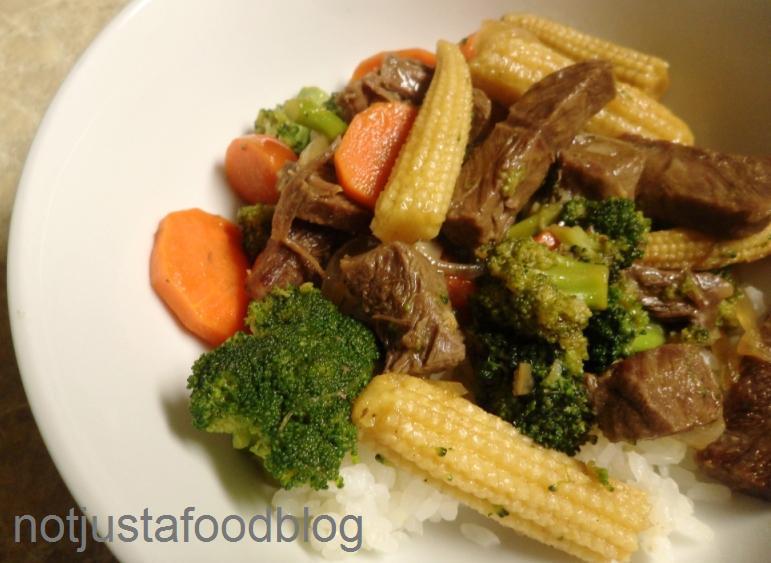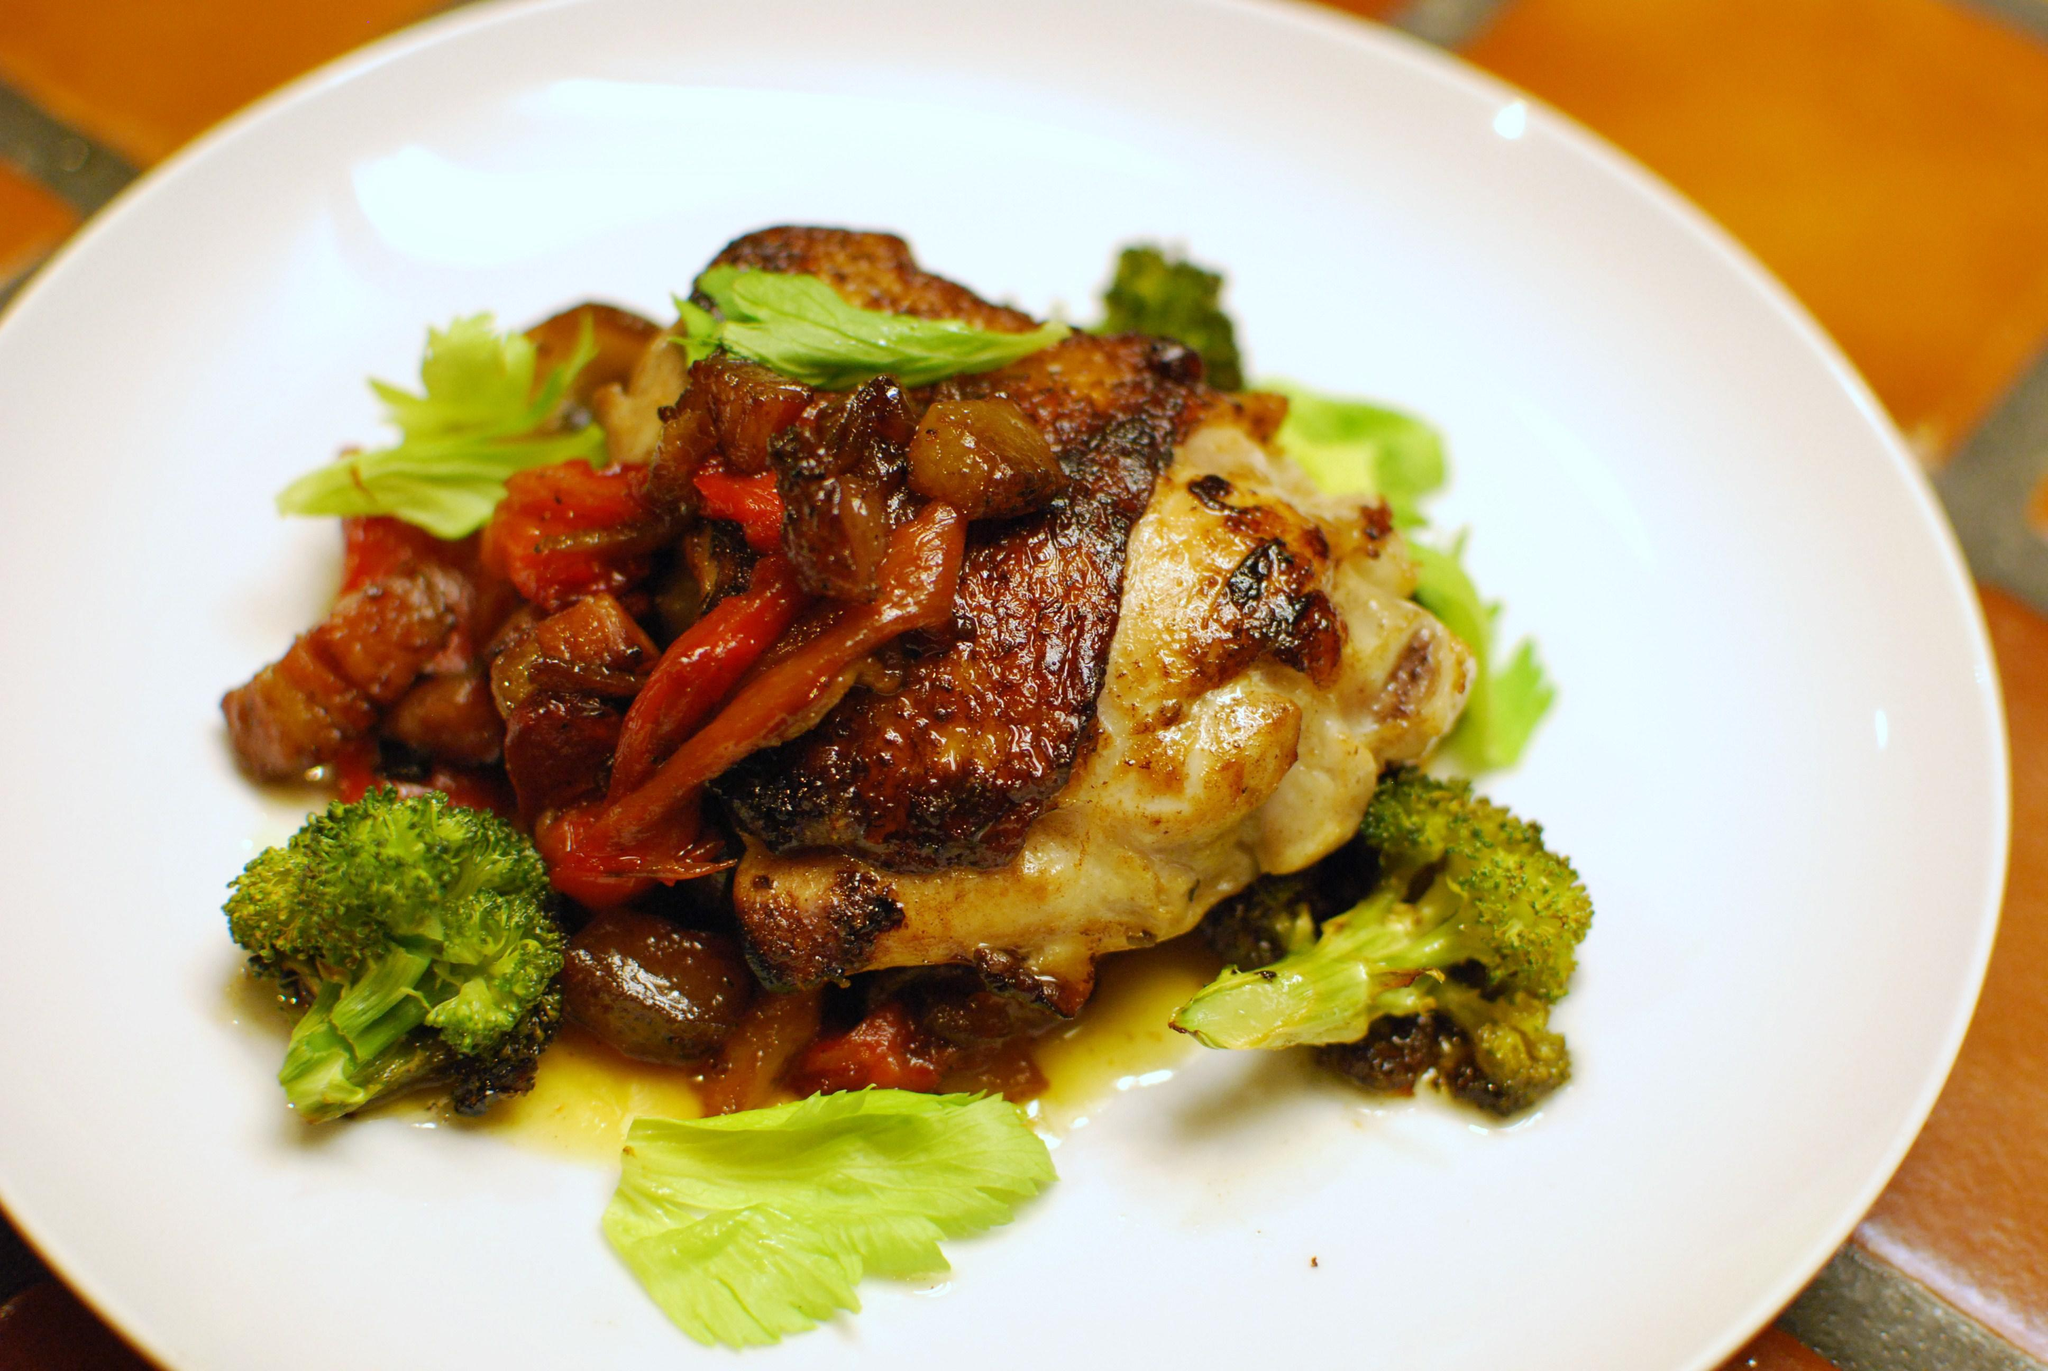The first image is the image on the left, the second image is the image on the right. For the images shown, is this caption "Broccoli stir fry is being served in the center of two white plates." true? Answer yes or no. Yes. The first image is the image on the left, the second image is the image on the right. Analyze the images presented: Is the assertion "The left and right image contains the same number of white plates with broccoli and beef." valid? Answer yes or no. Yes. 